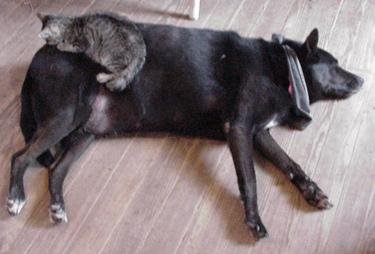Connect the visual elements seen in the image with emotions or sentiments. The cozy scene of a cat and dog together in peaceful sleep with elements of friendship and trust emanates a sentiment of warmth, love, and harmony. What is the physical interaction happening between the cat and the dog in the image, and what does it signify? The cat uses the dog as a pillow while laying on it, signifying a friendly and comfortable dynamic between the two animals. Comment on the uniqueness or oddity of the image, and whether it represents something uncommon or peculiar. The image is somewhat unusual, as it shows a cat and dog sleeping contentedly on top of each other, which may not be a common occurrence in animal interactions. List the various appearance attributes of the cat and its current state. The cat is grey with stripes, looks cute, and appears curled up and asleep as it lays on top of the dog. What are the notable features of the dog in the image and how does it seem to be feeling? The large black dog is wearing a grey bandana, has white paws, and appears to be asleep, not minding the cat sleeping on top of it. In a poetic manner, describe the main focus of the image. Amidst the gentle slumber of a sleepy grey cat and a large, snoozing black dog, a bond of friendship warms the heart and the wooden floor beneath. What is the primary activity happening in the image between the two animals? A cat is sleeping on top of a large black dog, both appearing as friends lying on a wooden floor. Mention the significant colors and materials visible in the scene. There's a grey-striped cat, a black dog, a brown wooden floor, and a grey bandana. Describe the primary visual components in the image by their spatial locations within the frame. Towards the center of the frame, there is a large black dog with a grey cat sleeping on it, both lying on a wooden floor. Choose one question that would be suitable for a VQA task pertaining to this image. What color is the bandana that the dog is wearing? 